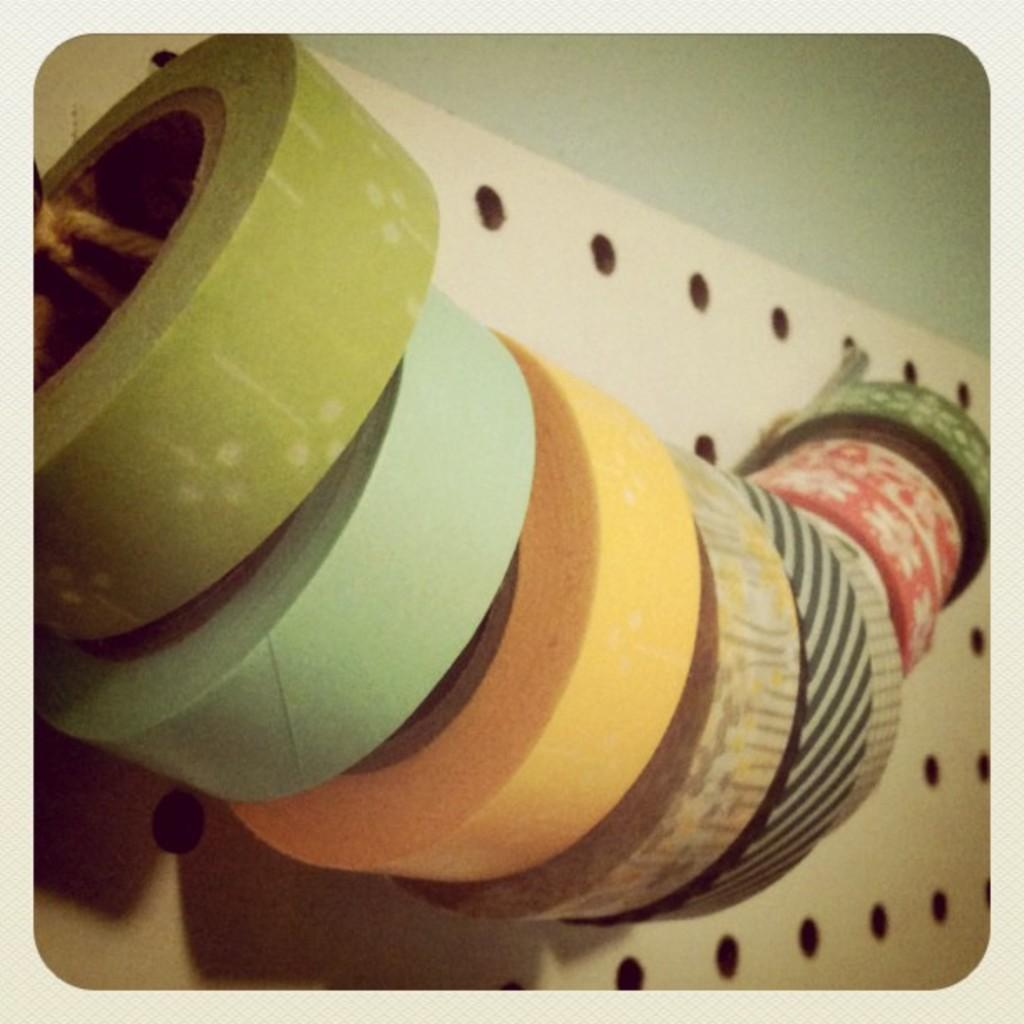What objects are present in the image? There are tape rolls in the image. How are the tape rolls arranged or positioned? The tape rolls are hanged to a rope. What can be said about the appearance of the tape rolls? The tape rolls are colorful. What can be observed about the background of the image? There is a white and green background in the image. Can you tell me how many people are involved in the argument in the image? There is no argument present in the image; it features tape rolls hanging on a rope. What type of flock is visible in the image? There is no flock present in the image; it features tape rolls hanging on a rope. 